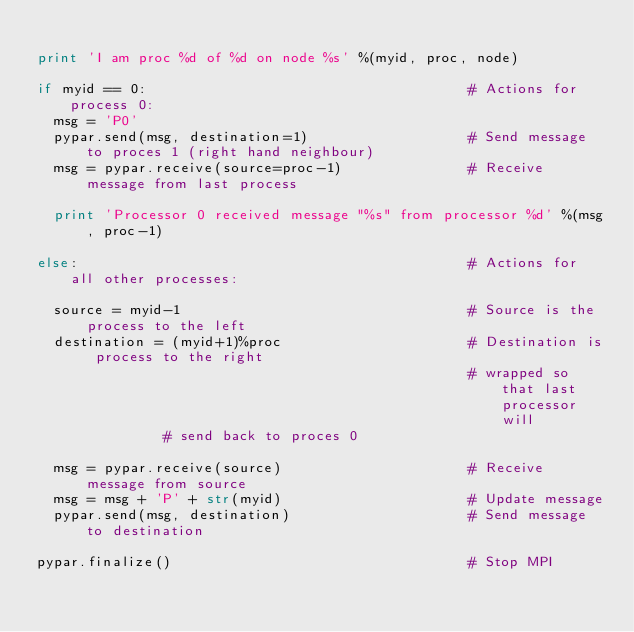Convert code to text. <code><loc_0><loc_0><loc_500><loc_500><_Python_>
print 'I am proc %d of %d on node %s' %(myid, proc, node)

if myid == 0:                                      # Actions for process 0:
  msg = 'P0'  
  pypar.send(msg, destination=1)                   # Send message to proces 1 (right hand neighbour)
  msg = pypar.receive(source=proc-1)               # Receive message from last process
      
  print 'Processor 0 received message "%s" from processor %d' %(msg, proc-1)

else:                                              # Actions for all other processes:

  source = myid-1                                  # Source is the process to the left
  destination = (myid+1)%proc                      # Destination is process to the right
                                                   # wrapped so that last processor will 
						   # send back to proces 0  
  
  msg = pypar.receive(source)                      # Receive message from source 
  msg = msg + 'P' + str(myid)                      # Update message     
  pypar.send(msg, destination)                     # Send message to destination   

pypar.finalize()                                   # Stop MPI 
</code> 